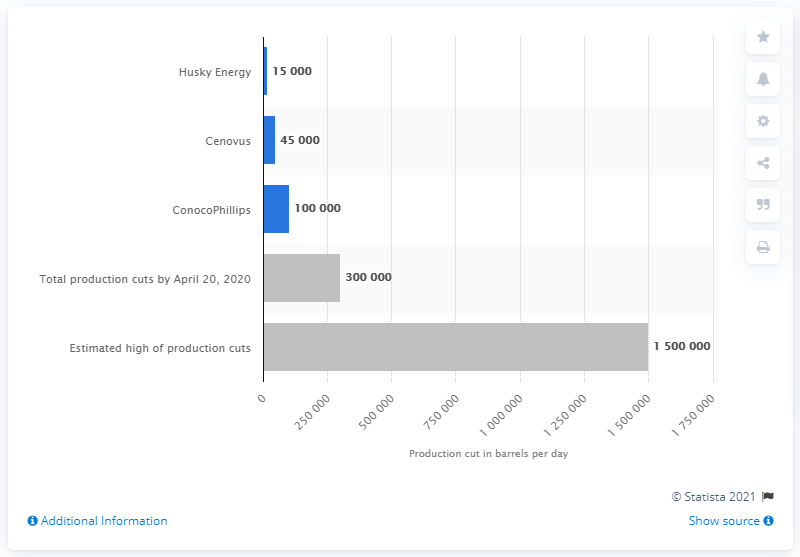Indicate a few pertinent items in this graphic. We propose reducing daily production in Canada by 150,000 barrels. 